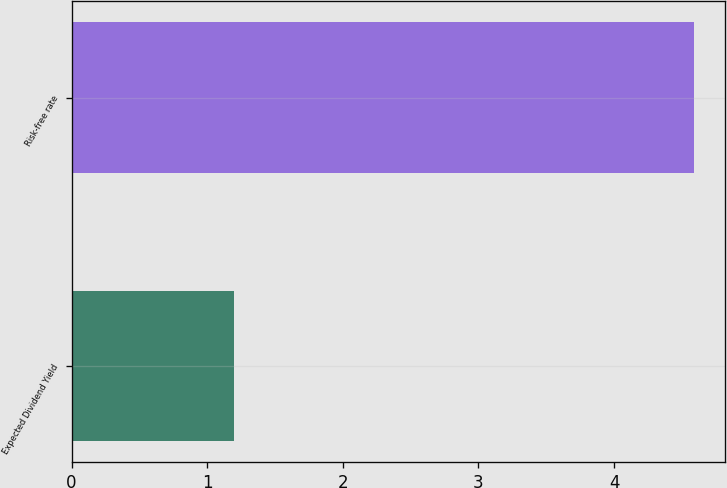<chart> <loc_0><loc_0><loc_500><loc_500><bar_chart><fcel>Expected Dividend Yield<fcel>Risk-free rate<nl><fcel>1.2<fcel>4.59<nl></chart> 